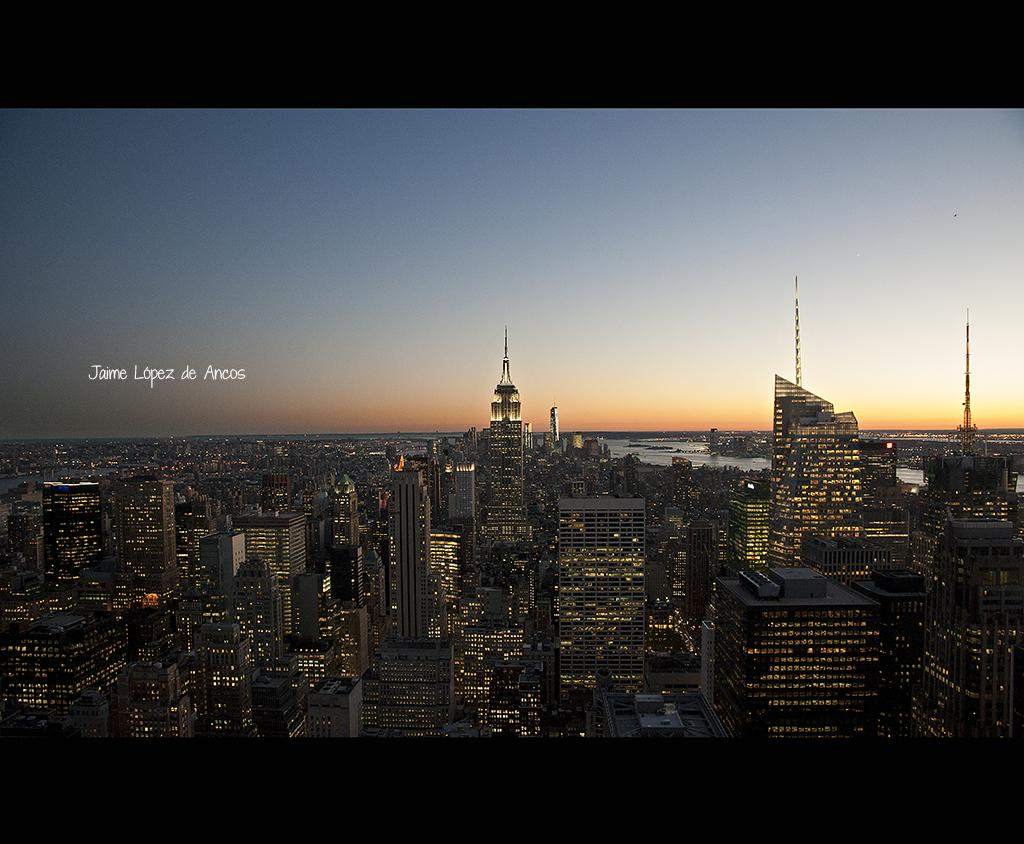What is the primary subject of the image? The primary subject of the image is many buildings. Can you describe the buildings in the image? Unfortunately, the provided facts do not include any details about the buildings. Are there any other elements in the image besides the buildings? The provided facts do not mention any other elements in the image. What type of wool is being used to plough the field in the image? There is no field or ploughing activity present in the image; it features many buildings. Who is the owner of the wool-producing sheep in the image? There are no sheep or wool-related activities present in the image. 